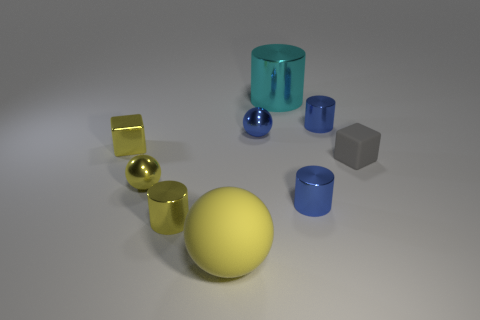Add 1 gray matte blocks. How many objects exist? 10 Subtract all cylinders. How many objects are left? 5 Add 5 gray blocks. How many gray blocks exist? 6 Subtract 0 red cylinders. How many objects are left? 9 Subtract all big yellow matte things. Subtract all tiny blue metal spheres. How many objects are left? 7 Add 4 metal blocks. How many metal blocks are left? 5 